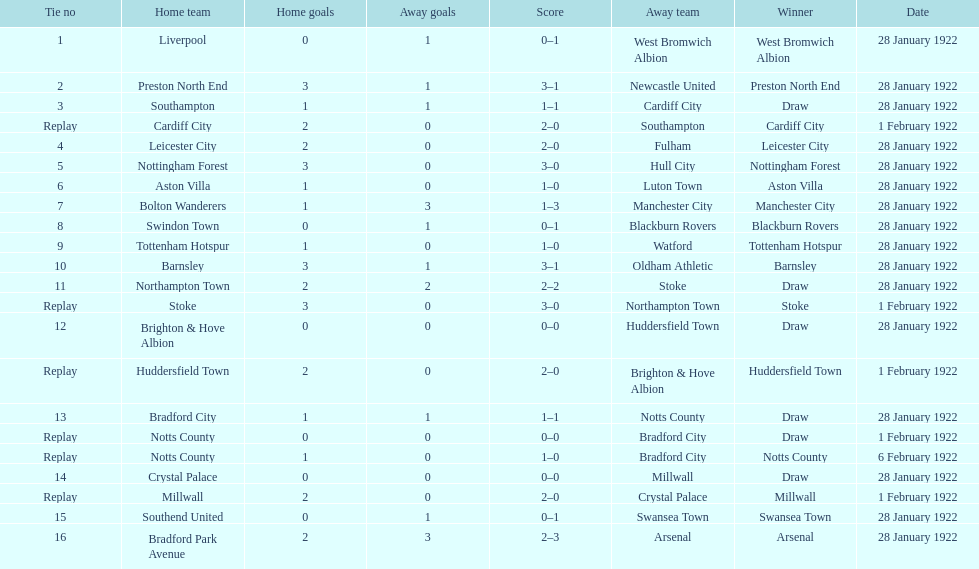How many games had four total points scored or more? 5. 